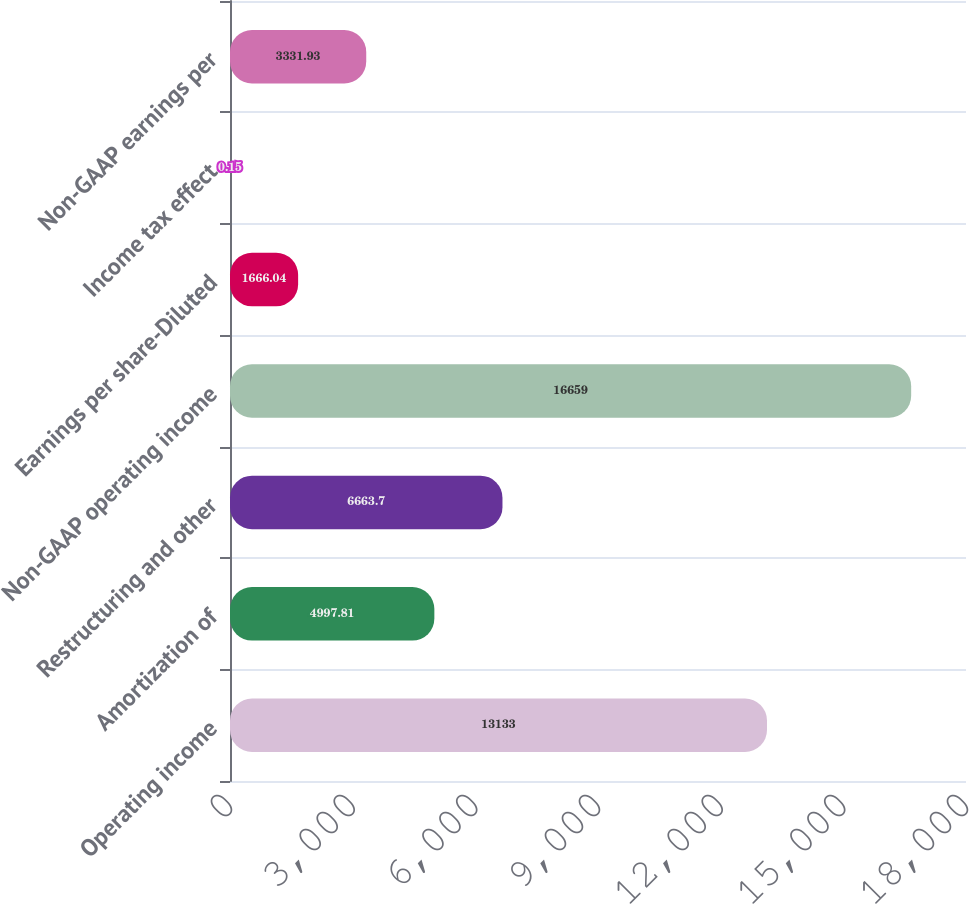Convert chart to OTSL. <chart><loc_0><loc_0><loc_500><loc_500><bar_chart><fcel>Operating income<fcel>Amortization of<fcel>Restructuring and other<fcel>Non-GAAP operating income<fcel>Earnings per share-Diluted<fcel>Income tax effect<fcel>Non-GAAP earnings per<nl><fcel>13133<fcel>4997.81<fcel>6663.7<fcel>16659<fcel>1666.04<fcel>0.15<fcel>3331.93<nl></chart> 